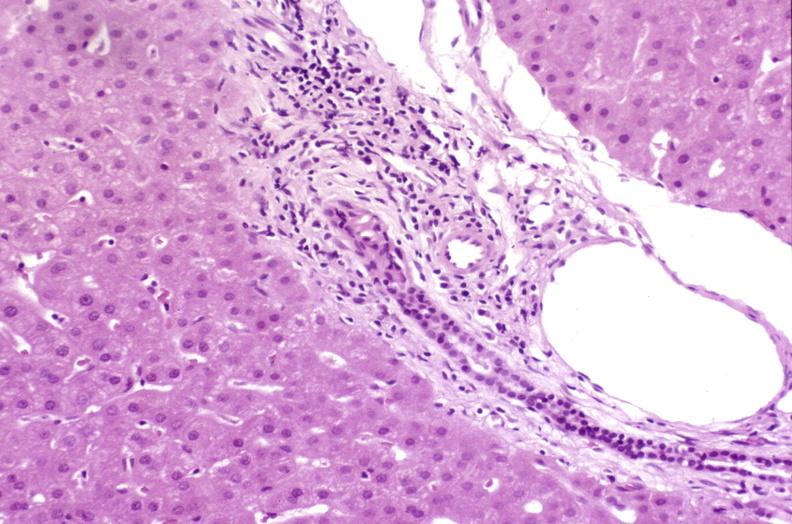what does this image show?
Answer the question using a single word or phrase. Resolving acute rejection 